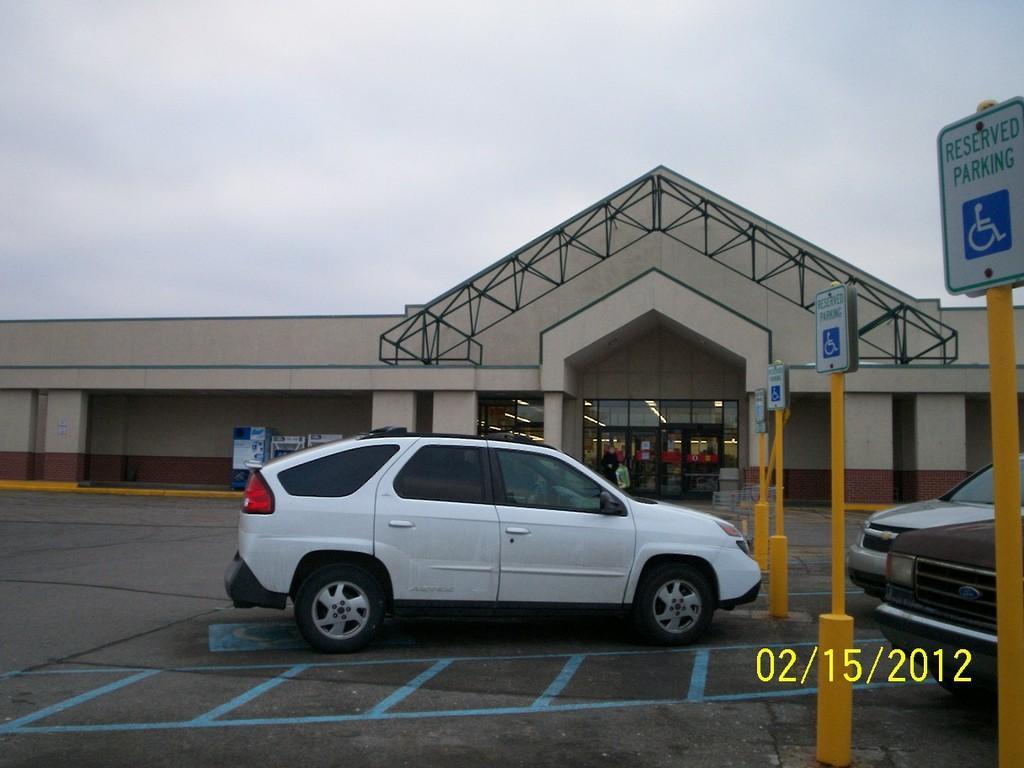Can you describe this image briefly? In the image I can see a building and a car in front of it and also I can see some poles to which there are some boards. 